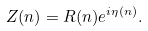<formula> <loc_0><loc_0><loc_500><loc_500>Z ( n ) = R ( n ) e ^ { i \eta ( n ) } .</formula> 